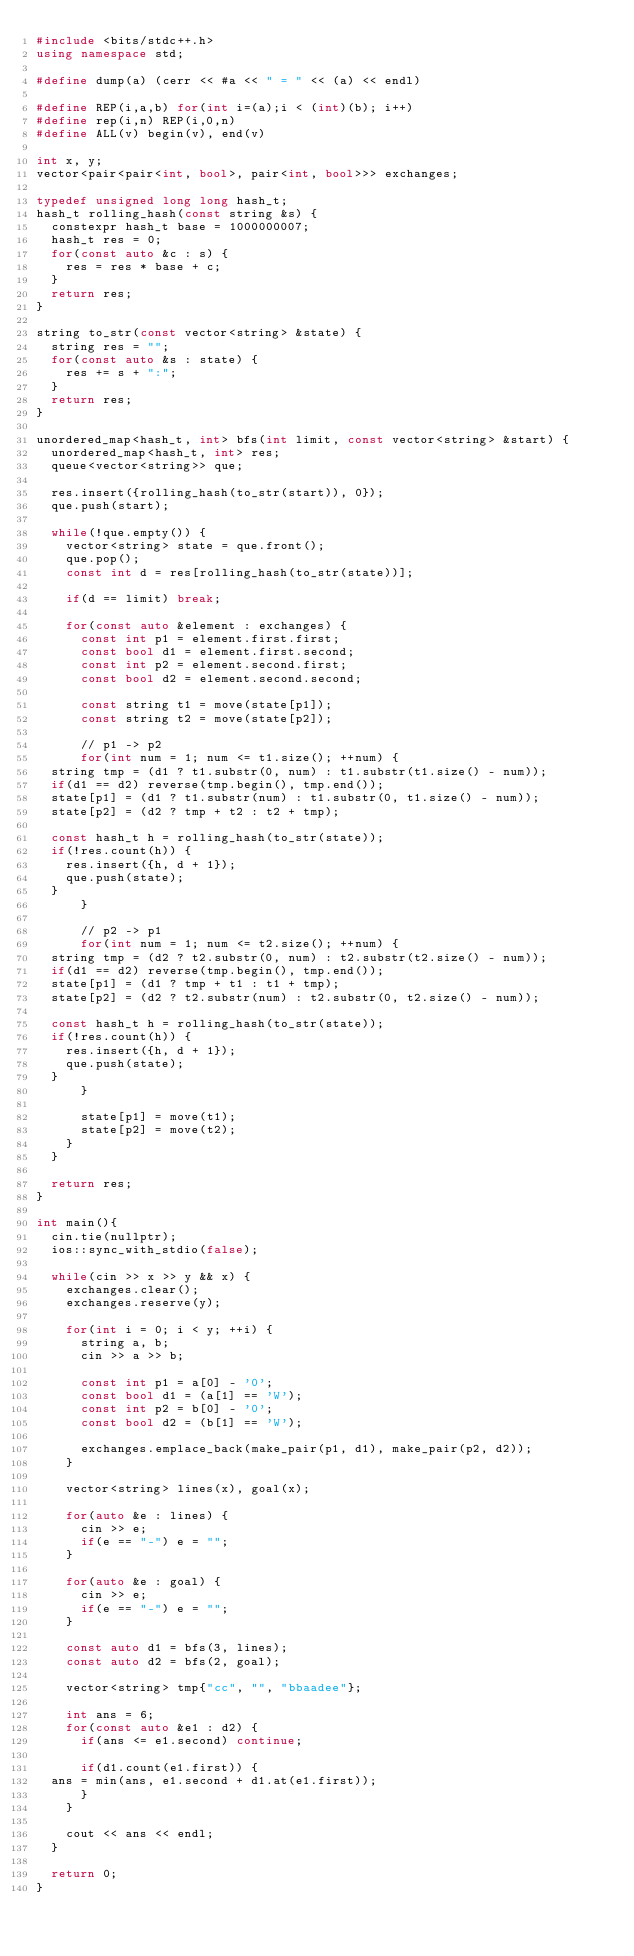Convert code to text. <code><loc_0><loc_0><loc_500><loc_500><_C++_>#include <bits/stdc++.h>
using namespace std;

#define dump(a) (cerr << #a << " = " << (a) << endl)

#define REP(i,a,b) for(int i=(a);i < (int)(b); i++)
#define rep(i,n) REP(i,0,n)
#define ALL(v) begin(v), end(v)

int x, y;
vector<pair<pair<int, bool>, pair<int, bool>>> exchanges;

typedef unsigned long long hash_t;
hash_t rolling_hash(const string &s) {
  constexpr hash_t base = 1000000007;
  hash_t res = 0;
  for(const auto &c : s) {
    res = res * base + c;
  }
  return res;
}

string to_str(const vector<string> &state) {
  string res = "";
  for(const auto &s : state) {
    res += s + ":";
  }
  return res;
}

unordered_map<hash_t, int> bfs(int limit, const vector<string> &start) {
  unordered_map<hash_t, int> res;
  queue<vector<string>> que;

  res.insert({rolling_hash(to_str(start)), 0});
  que.push(start);

  while(!que.empty()) {
    vector<string> state = que.front();
    que.pop();
    const int d = res[rolling_hash(to_str(state))];

    if(d == limit) break;

    for(const auto &element : exchanges) {
      const int p1 = element.first.first;
      const bool d1 = element.first.second;
      const int p2 = element.second.first;
      const bool d2 = element.second.second;

      const string t1 = move(state[p1]);
      const string t2 = move(state[p2]);

      // p1 -> p2
      for(int num = 1; num <= t1.size(); ++num) {
	string tmp = (d1 ? t1.substr(0, num) : t1.substr(t1.size() - num));
	if(d1 == d2) reverse(tmp.begin(), tmp.end());
	state[p1] = (d1 ? t1.substr(num) : t1.substr(0, t1.size() - num));
	state[p2] = (d2 ? tmp + t2 : t2 + tmp);

	const hash_t h = rolling_hash(to_str(state));
	if(!res.count(h)) {
	  res.insert({h, d + 1});
	  que.push(state);
	}
      }

      // p2 -> p1
      for(int num = 1; num <= t2.size(); ++num) {
	string tmp = (d2 ? t2.substr(0, num) : t2.substr(t2.size() - num));
	if(d1 == d2) reverse(tmp.begin(), tmp.end());
	state[p1] = (d1 ? tmp + t1 : t1 + tmp);
	state[p2] = (d2 ? t2.substr(num) : t2.substr(0, t2.size() - num));

	const hash_t h = rolling_hash(to_str(state));
	if(!res.count(h)) {
	  res.insert({h, d + 1});
	  que.push(state);
	}
      }

      state[p1] = move(t1);
      state[p2] = move(t2);
    }
  }

  return res;
}

int main(){
  cin.tie(nullptr);
  ios::sync_with_stdio(false);

  while(cin >> x >> y && x) {
    exchanges.clear();
    exchanges.reserve(y);

    for(int i = 0; i < y; ++i) {
      string a, b;
      cin >> a >> b;

      const int p1 = a[0] - '0';
      const bool d1 = (a[1] == 'W');
      const int p2 = b[0] - '0';
      const bool d2 = (b[1] == 'W');

      exchanges.emplace_back(make_pair(p1, d1), make_pair(p2, d2));
    }

    vector<string> lines(x), goal(x);

    for(auto &e : lines) {
      cin >> e;
      if(e == "-") e = "";
    }

    for(auto &e : goal) {
      cin >> e;
      if(e == "-") e = "";
    }
    
    const auto d1 = bfs(3, lines);
    const auto d2 = bfs(2, goal);

    vector<string> tmp{"cc", "", "bbaadee"};

    int ans = 6;
    for(const auto &e1 : d2) {
      if(ans <= e1.second) continue;

      if(d1.count(e1.first)) {
	ans = min(ans, e1.second + d1.at(e1.first));
      }
    }

    cout << ans << endl;
  }

  return 0;
}</code> 